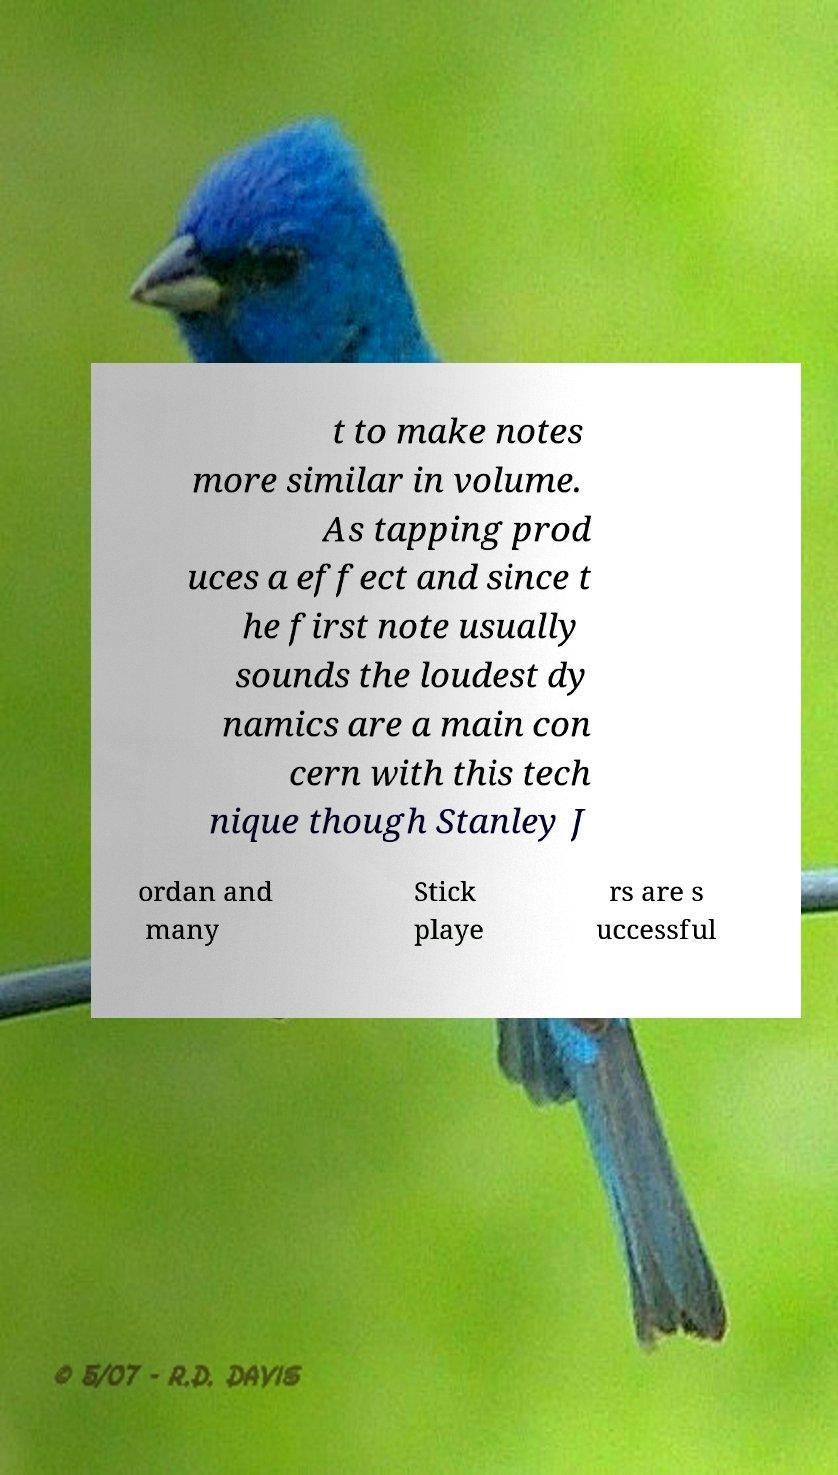Could you assist in decoding the text presented in this image and type it out clearly? t to make notes more similar in volume. As tapping prod uces a effect and since t he first note usually sounds the loudest dy namics are a main con cern with this tech nique though Stanley J ordan and many Stick playe rs are s uccessful 